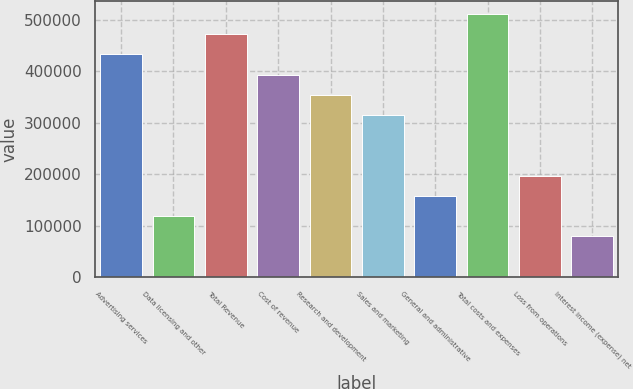Convert chart to OTSL. <chart><loc_0><loc_0><loc_500><loc_500><bar_chart><fcel>Advertising services<fcel>Data licensing and other<fcel>Total Revenue<fcel>Cost of revenue<fcel>Research and development<fcel>Sales and marketing<fcel>General and administrative<fcel>Total costs and expenses<fcel>Loss from operations<fcel>Interest income (expense) net<nl><fcel>433395<fcel>118365<fcel>472773<fcel>394016<fcel>354637<fcel>315259<fcel>157744<fcel>512152<fcel>197122<fcel>78986.4<nl></chart> 